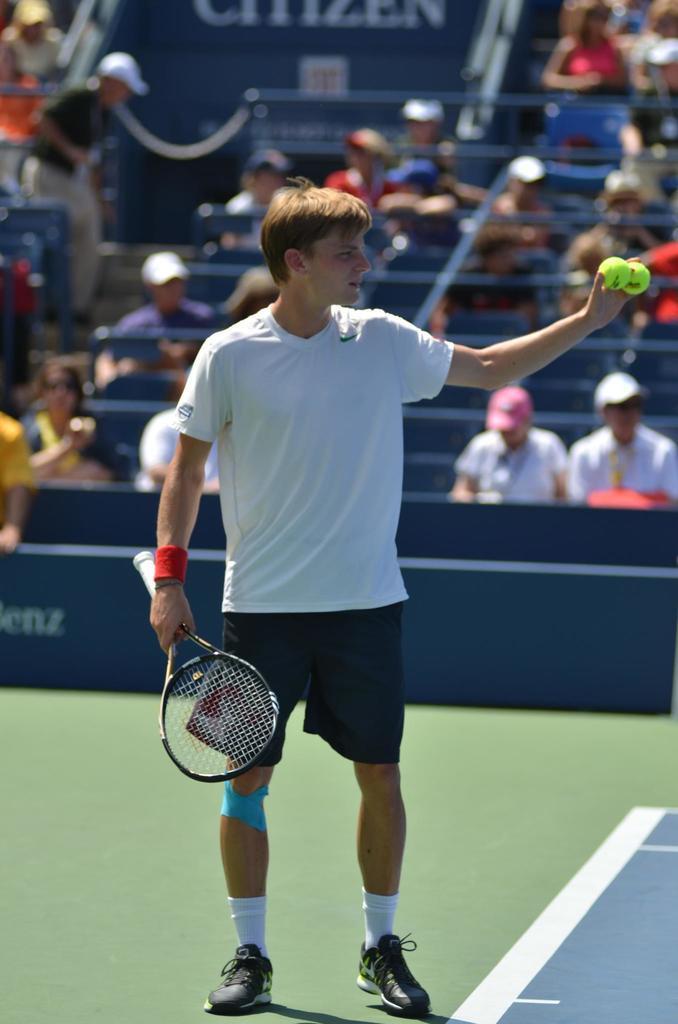Describe this image in one or two sentences. This image is clicked in a stadium. The man in the center is holding a racket in his right hand and tennis balls in his left hand. Behind him there are people sitting on chairs and there are also steps. 